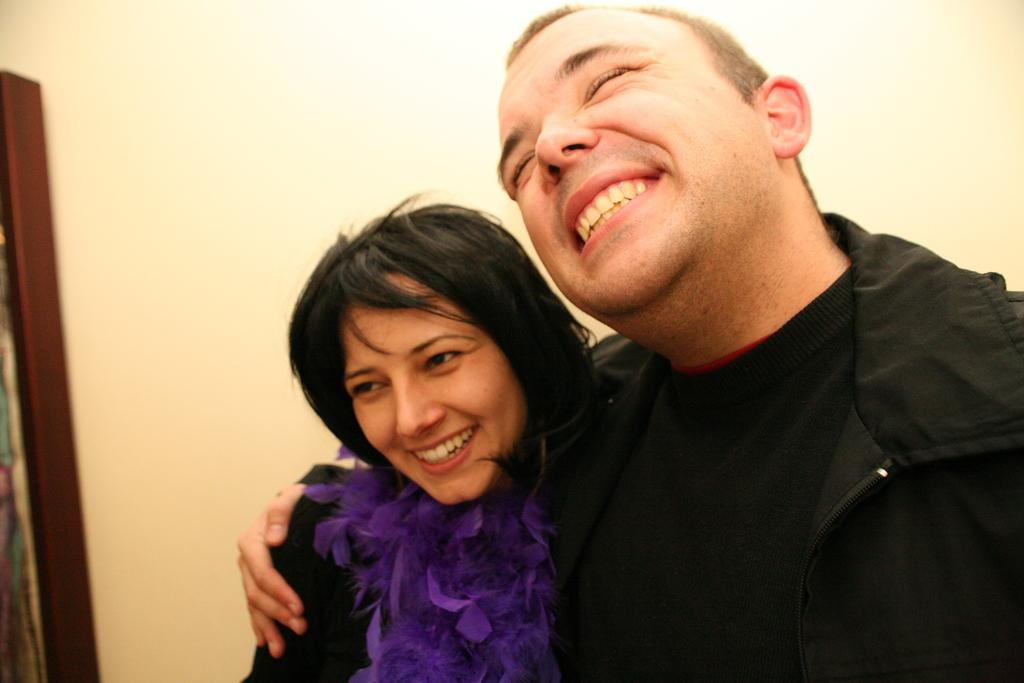What is the main subject of the image? There is a person in the image. What is the person wearing? The person is wearing a black jacket. What is the person's facial expression? The person is smiling. How is the person interacting with the woman beside him? The person has one hand on the woman beside him. What can be seen in the left corner of the image? There is an object in the left corner of the image. What invention is the person holding in the image? There is no invention visible in the image; the person is not holding anything. Can you see any ghosts in the image? There are no ghosts present in the image. 